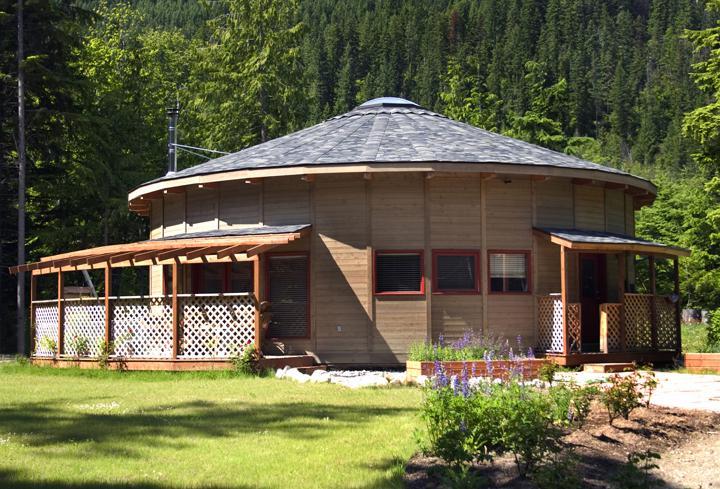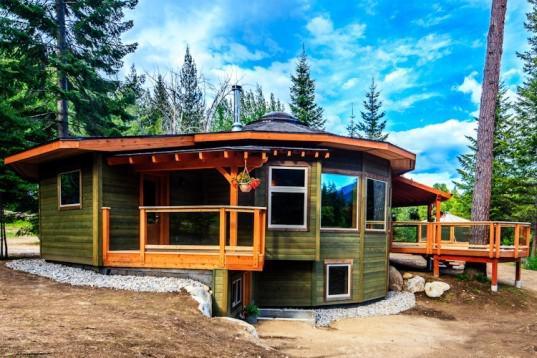The first image is the image on the left, the second image is the image on the right. Given the left and right images, does the statement "One building has green grass growing on its room." hold true? Answer yes or no. No. The first image is the image on the left, the second image is the image on the right. For the images shown, is this caption "The structures in the right image have grass on the roof." true? Answer yes or no. No. 